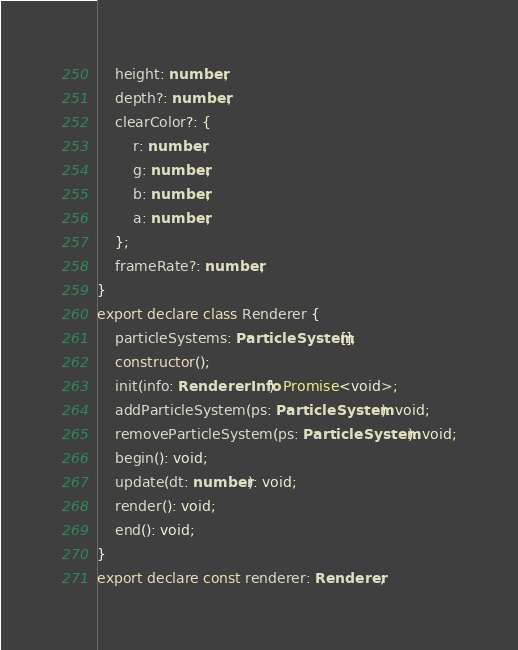Convert code to text. <code><loc_0><loc_0><loc_500><loc_500><_TypeScript_>    height: number;
    depth?: number;
    clearColor?: {
        r: number;
        g: number;
        b: number;
        a: number;
    };
    frameRate?: number;
}
export declare class Renderer {
    particleSystems: ParticleSystem[];
    constructor();
    init(info: RendererInfo): Promise<void>;
    addParticleSystem(ps: ParticleSystem): void;
    removeParticleSystem(ps: ParticleSystem): void;
    begin(): void;
    update(dt: number): void;
    render(): void;
    end(): void;
}
export declare const renderer: Renderer;
</code> 